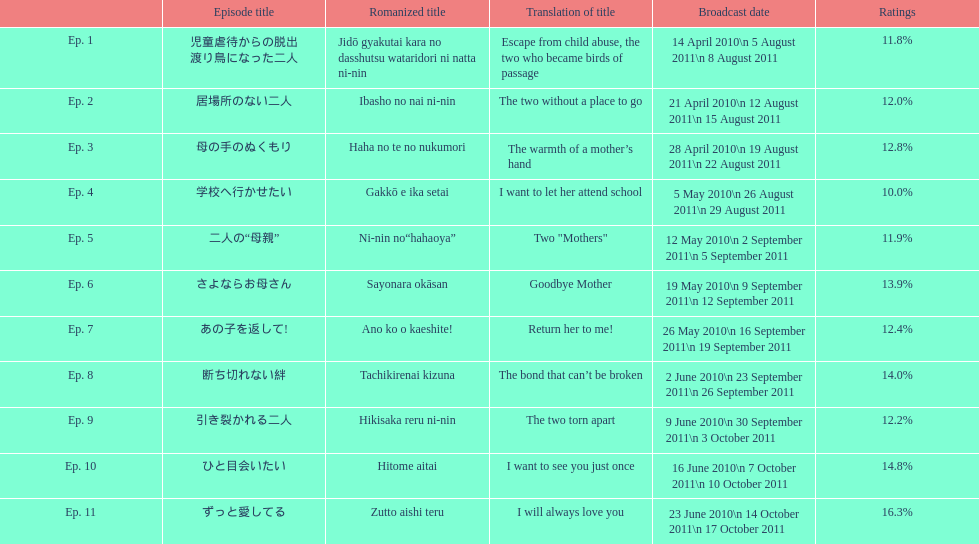How many episodes were broadcast in april 2010 in japan? 3. 